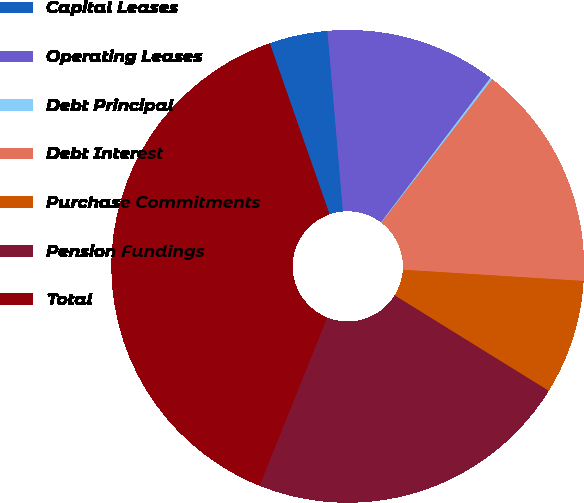Convert chart. <chart><loc_0><loc_0><loc_500><loc_500><pie_chart><fcel>Capital Leases<fcel>Operating Leases<fcel>Debt Principal<fcel>Debt Interest<fcel>Purchase Commitments<fcel>Pension Fundings<fcel>Total<nl><fcel>3.99%<fcel>11.68%<fcel>0.15%<fcel>15.52%<fcel>7.84%<fcel>22.26%<fcel>38.56%<nl></chart> 